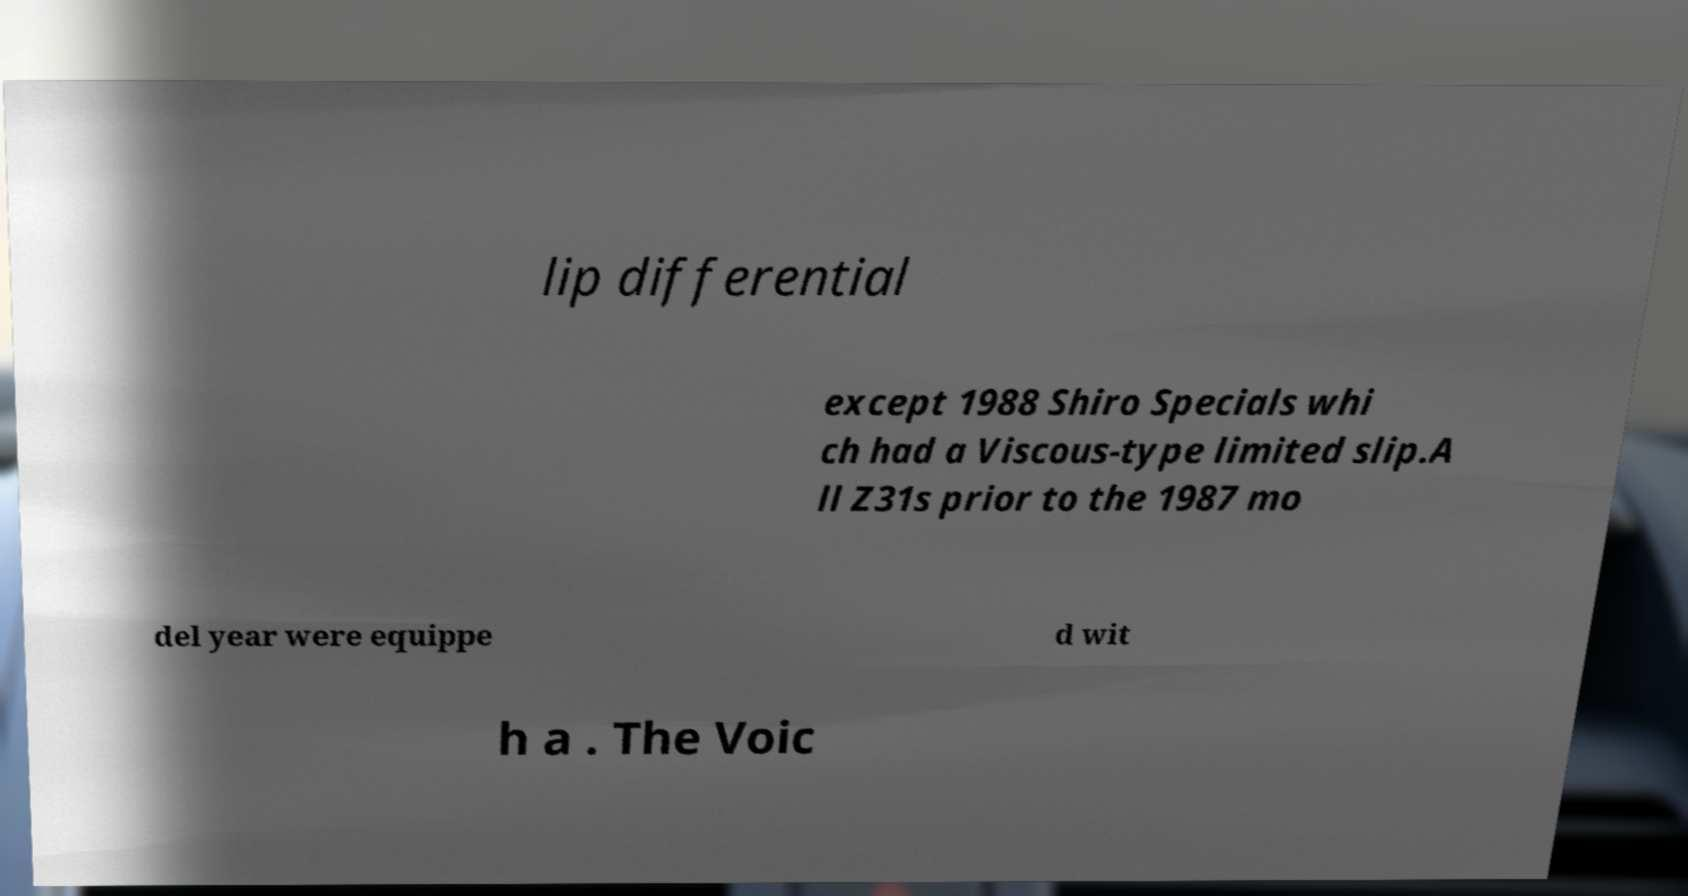For documentation purposes, I need the text within this image transcribed. Could you provide that? lip differential except 1988 Shiro Specials whi ch had a Viscous-type limited slip.A ll Z31s prior to the 1987 mo del year were equippe d wit h a . The Voic 